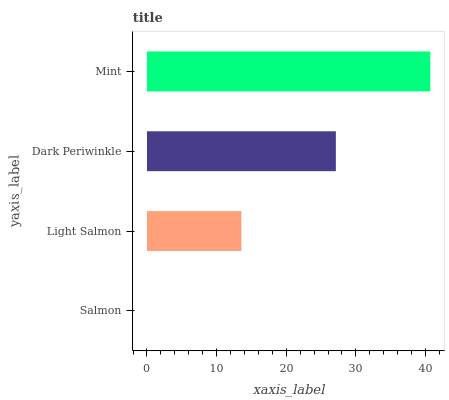Is Salmon the minimum?
Answer yes or no. Yes. Is Mint the maximum?
Answer yes or no. Yes. Is Light Salmon the minimum?
Answer yes or no. No. Is Light Salmon the maximum?
Answer yes or no. No. Is Light Salmon greater than Salmon?
Answer yes or no. Yes. Is Salmon less than Light Salmon?
Answer yes or no. Yes. Is Salmon greater than Light Salmon?
Answer yes or no. No. Is Light Salmon less than Salmon?
Answer yes or no. No. Is Dark Periwinkle the high median?
Answer yes or no. Yes. Is Light Salmon the low median?
Answer yes or no. Yes. Is Mint the high median?
Answer yes or no. No. Is Salmon the low median?
Answer yes or no. No. 